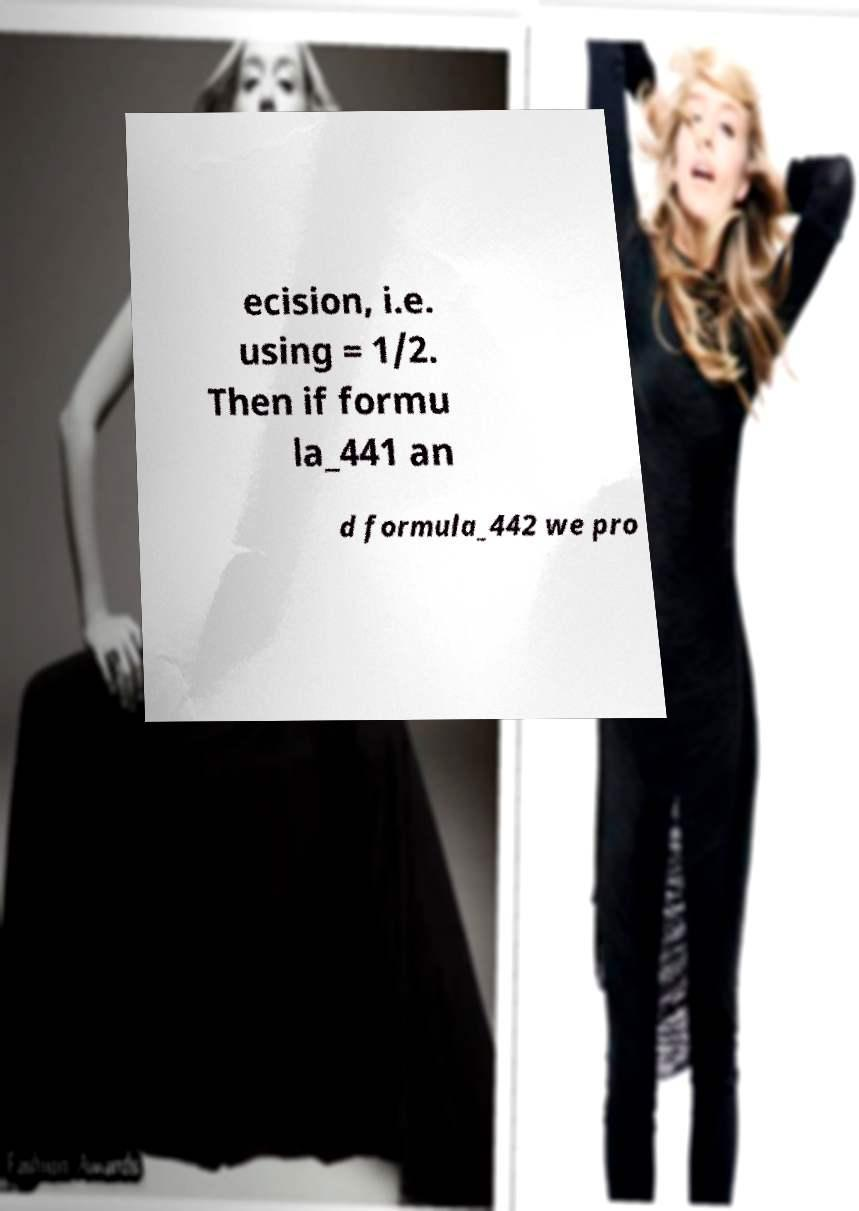Can you read and provide the text displayed in the image?This photo seems to have some interesting text. Can you extract and type it out for me? ecision, i.e. using = 1/2. Then if formu la_441 an d formula_442 we pro 